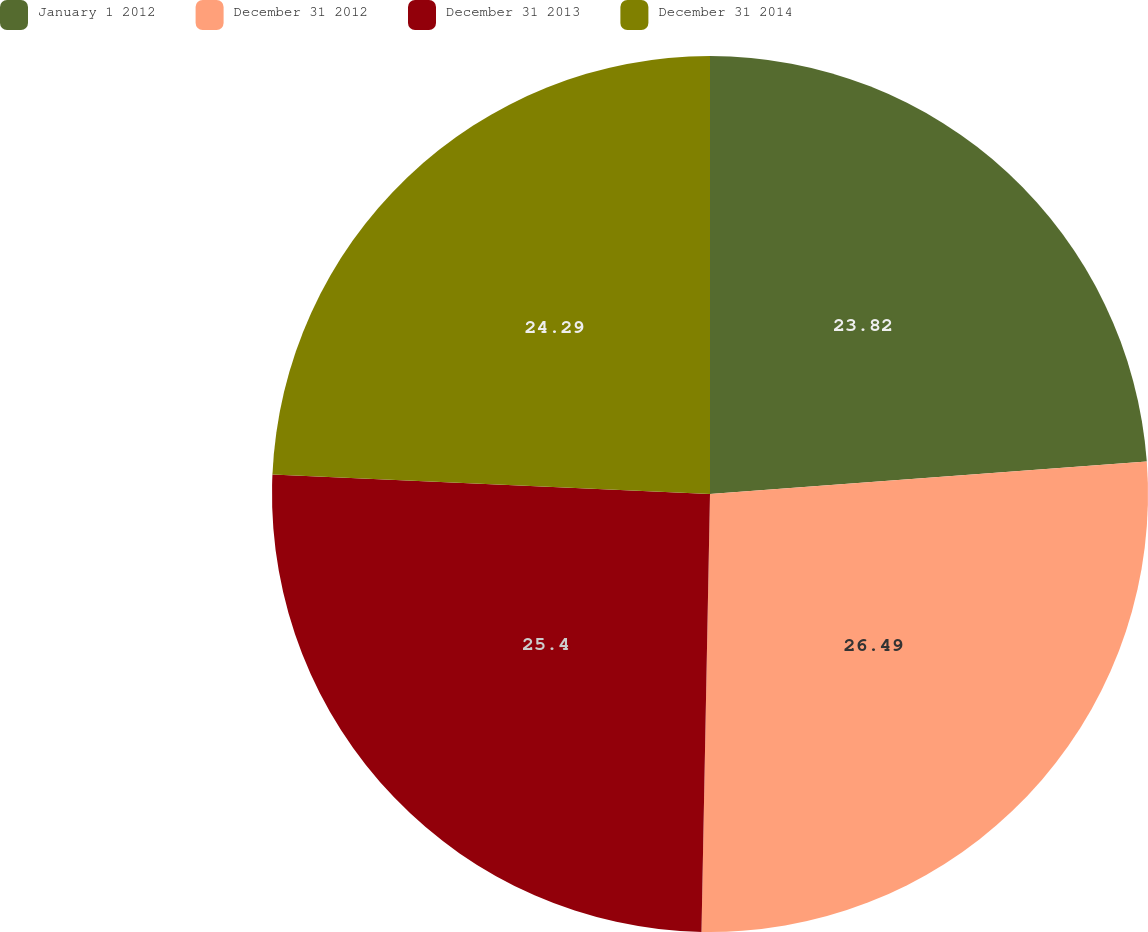Convert chart to OTSL. <chart><loc_0><loc_0><loc_500><loc_500><pie_chart><fcel>January 1 2012<fcel>December 31 2012<fcel>December 31 2013<fcel>December 31 2014<nl><fcel>23.82%<fcel>26.49%<fcel>25.4%<fcel>24.29%<nl></chart> 